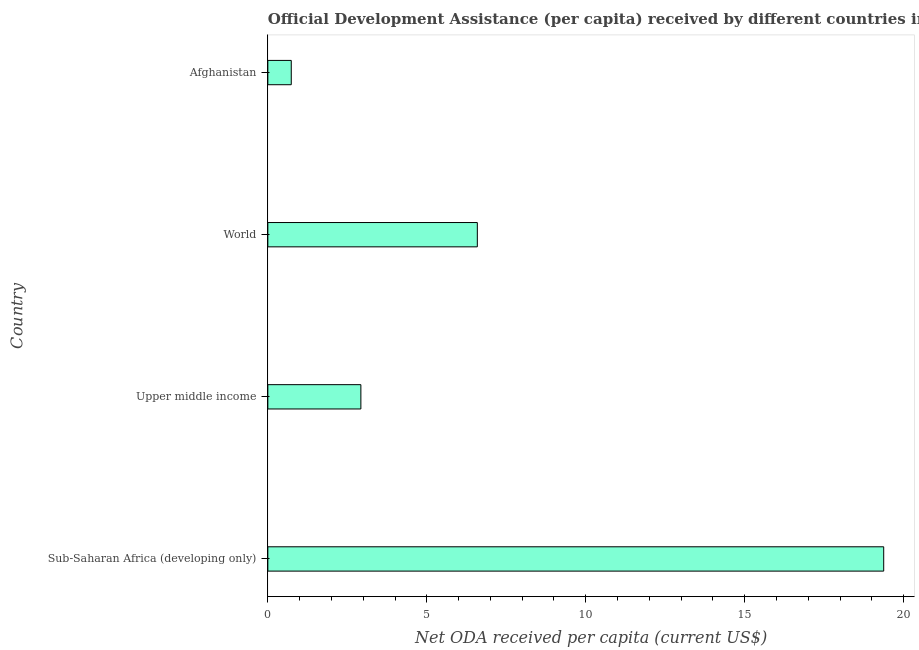Does the graph contain grids?
Keep it short and to the point. No. What is the title of the graph?
Ensure brevity in your answer.  Official Development Assistance (per capita) received by different countries in the year 1982. What is the label or title of the X-axis?
Keep it short and to the point. Net ODA received per capita (current US$). What is the label or title of the Y-axis?
Your answer should be compact. Country. What is the net oda received per capita in World?
Offer a terse response. 6.59. Across all countries, what is the maximum net oda received per capita?
Provide a short and direct response. 19.37. Across all countries, what is the minimum net oda received per capita?
Your answer should be very brief. 0.74. In which country was the net oda received per capita maximum?
Provide a short and direct response. Sub-Saharan Africa (developing only). In which country was the net oda received per capita minimum?
Make the answer very short. Afghanistan. What is the sum of the net oda received per capita?
Keep it short and to the point. 29.63. What is the difference between the net oda received per capita in Afghanistan and World?
Offer a terse response. -5.85. What is the average net oda received per capita per country?
Make the answer very short. 7.41. What is the median net oda received per capita?
Offer a very short reply. 4.76. In how many countries, is the net oda received per capita greater than 8 US$?
Provide a succinct answer. 1. What is the ratio of the net oda received per capita in Sub-Saharan Africa (developing only) to that in World?
Give a very brief answer. 2.94. Is the difference between the net oda received per capita in Afghanistan and Sub-Saharan Africa (developing only) greater than the difference between any two countries?
Your answer should be compact. Yes. What is the difference between the highest and the second highest net oda received per capita?
Provide a short and direct response. 12.78. Is the sum of the net oda received per capita in Afghanistan and Sub-Saharan Africa (developing only) greater than the maximum net oda received per capita across all countries?
Offer a very short reply. Yes. What is the difference between the highest and the lowest net oda received per capita?
Give a very brief answer. 18.64. How many bars are there?
Provide a short and direct response. 4. What is the difference between two consecutive major ticks on the X-axis?
Keep it short and to the point. 5. Are the values on the major ticks of X-axis written in scientific E-notation?
Provide a short and direct response. No. What is the Net ODA received per capita (current US$) of Sub-Saharan Africa (developing only)?
Your answer should be very brief. 19.37. What is the Net ODA received per capita (current US$) of Upper middle income?
Offer a terse response. 2.93. What is the Net ODA received per capita (current US$) of World?
Ensure brevity in your answer.  6.59. What is the Net ODA received per capita (current US$) of Afghanistan?
Your response must be concise. 0.74. What is the difference between the Net ODA received per capita (current US$) in Sub-Saharan Africa (developing only) and Upper middle income?
Ensure brevity in your answer.  16.45. What is the difference between the Net ODA received per capita (current US$) in Sub-Saharan Africa (developing only) and World?
Make the answer very short. 12.78. What is the difference between the Net ODA received per capita (current US$) in Sub-Saharan Africa (developing only) and Afghanistan?
Provide a succinct answer. 18.64. What is the difference between the Net ODA received per capita (current US$) in Upper middle income and World?
Your answer should be compact. -3.66. What is the difference between the Net ODA received per capita (current US$) in Upper middle income and Afghanistan?
Your response must be concise. 2.19. What is the difference between the Net ODA received per capita (current US$) in World and Afghanistan?
Ensure brevity in your answer.  5.85. What is the ratio of the Net ODA received per capita (current US$) in Sub-Saharan Africa (developing only) to that in Upper middle income?
Provide a succinct answer. 6.62. What is the ratio of the Net ODA received per capita (current US$) in Sub-Saharan Africa (developing only) to that in World?
Make the answer very short. 2.94. What is the ratio of the Net ODA received per capita (current US$) in Sub-Saharan Africa (developing only) to that in Afghanistan?
Your answer should be very brief. 26.3. What is the ratio of the Net ODA received per capita (current US$) in Upper middle income to that in World?
Your answer should be very brief. 0.44. What is the ratio of the Net ODA received per capita (current US$) in Upper middle income to that in Afghanistan?
Your answer should be compact. 3.97. What is the ratio of the Net ODA received per capita (current US$) in World to that in Afghanistan?
Your response must be concise. 8.95. 